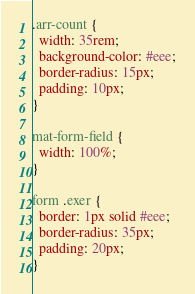Convert code to text. <code><loc_0><loc_0><loc_500><loc_500><_CSS_>.arr-count {
  width: 35rem;
  background-color: #eee;
  border-radius: 15px;
  padding: 10px;
}

mat-form-field {
  width: 100%;
}

form .exer {
  border: 1px solid #eee;
  border-radius: 35px;
  padding: 20px;
}
</code> 